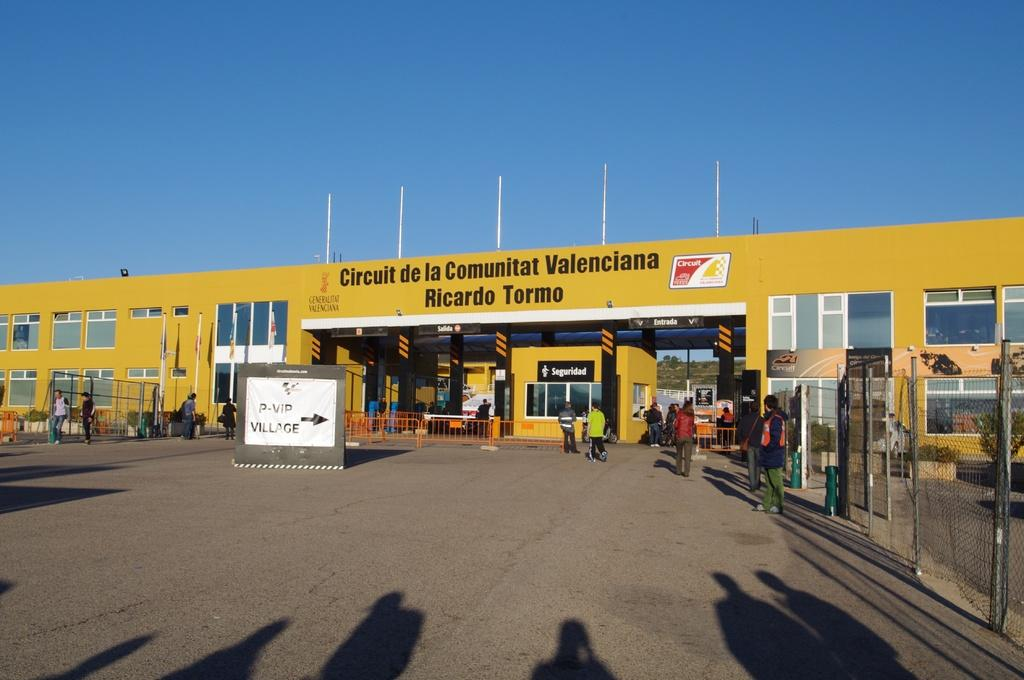<image>
Share a concise interpretation of the image provided. the outside of a building that says 'circuit de la communitat valenciana ricardo tormo' at the top 